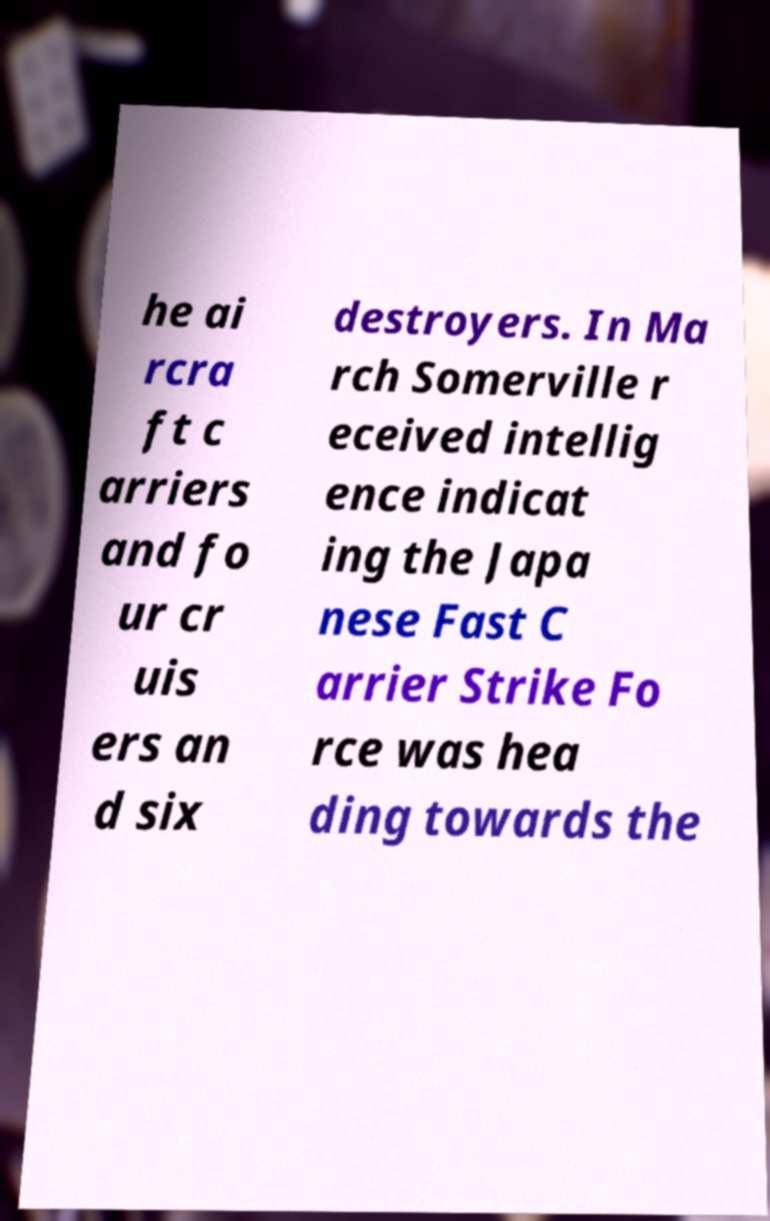I need the written content from this picture converted into text. Can you do that? he ai rcra ft c arriers and fo ur cr uis ers an d six destroyers. In Ma rch Somerville r eceived intellig ence indicat ing the Japa nese Fast C arrier Strike Fo rce was hea ding towards the 